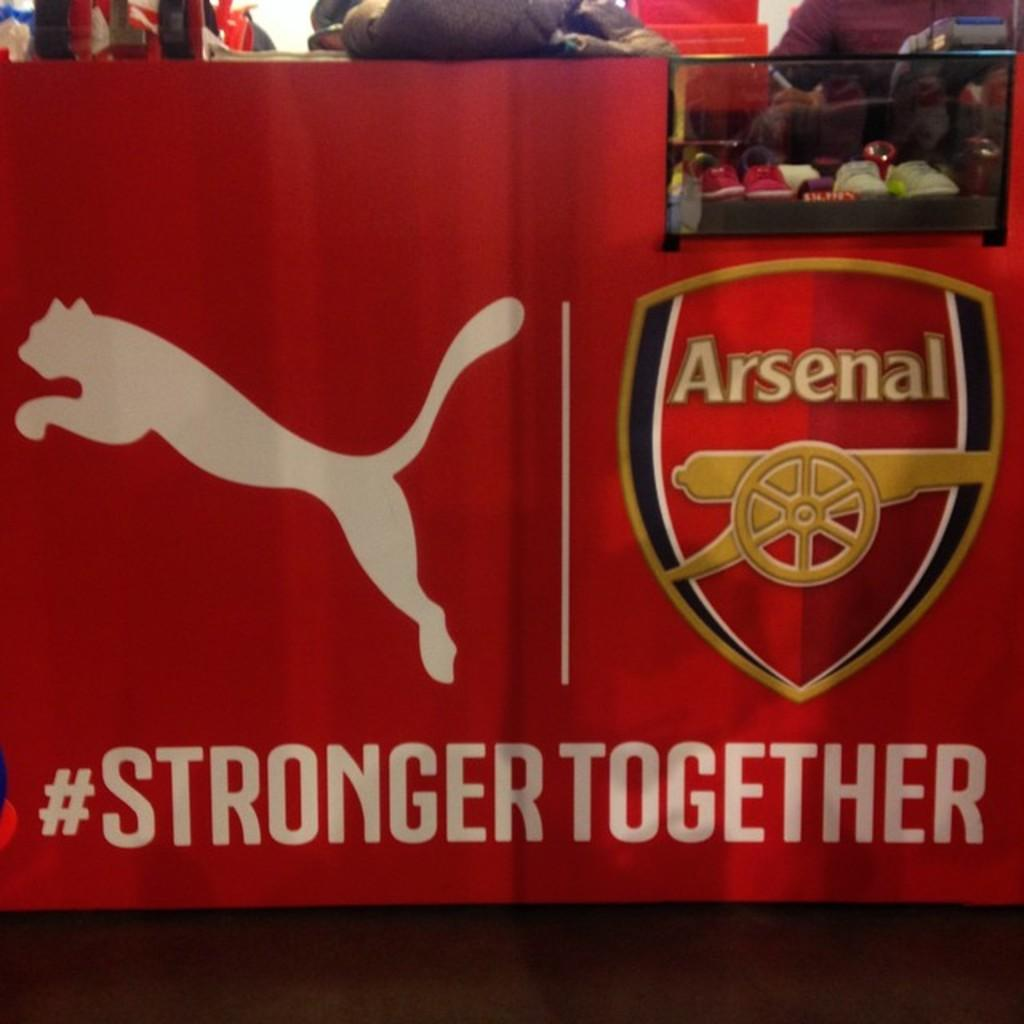<image>
Summarize the visual content of the image. A pair of red and white shoes sit in a case that says #strongertogether underneath 